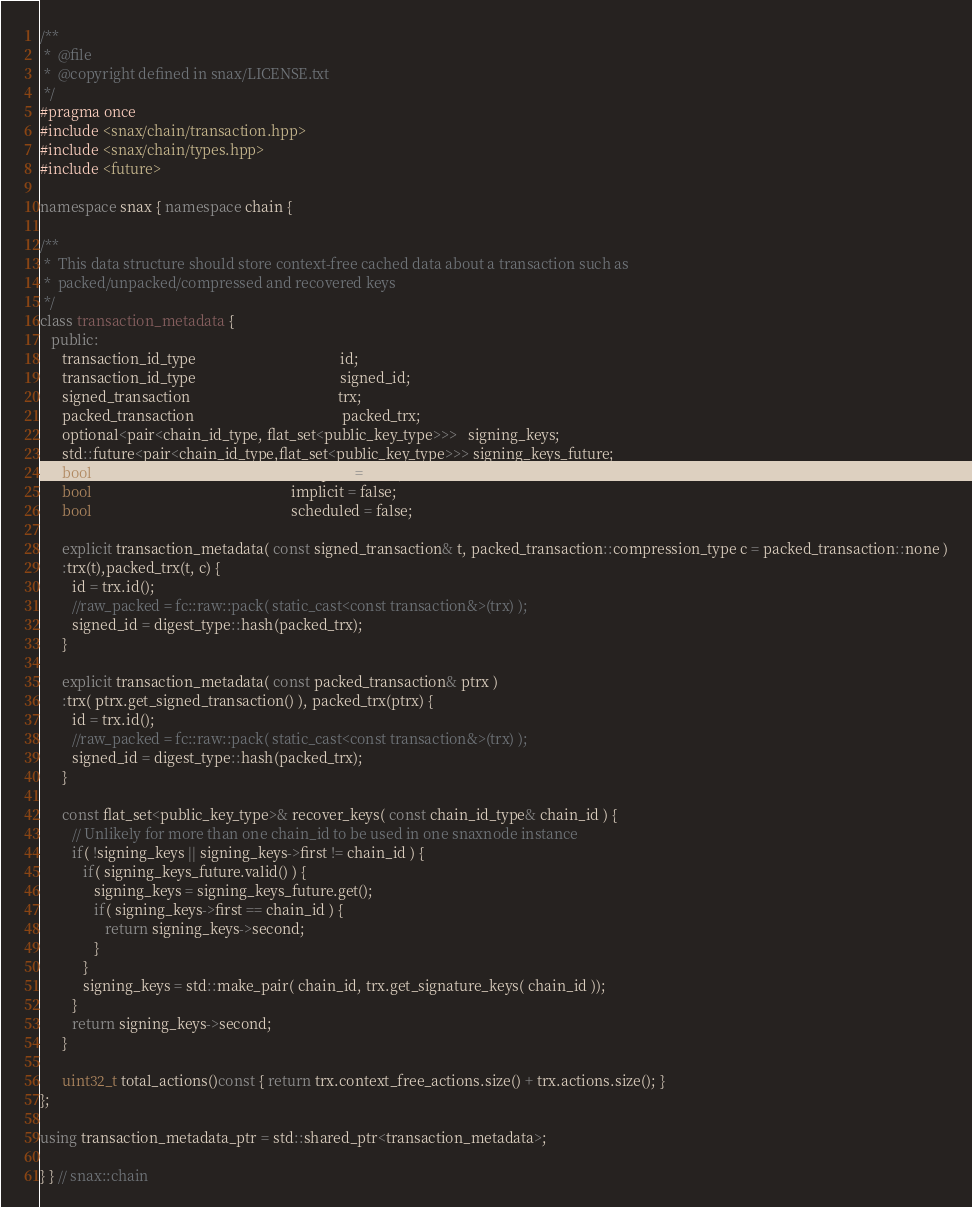<code> <loc_0><loc_0><loc_500><loc_500><_C++_>/**
 *  @file
 *  @copyright defined in snax/LICENSE.txt
 */
#pragma once
#include <snax/chain/transaction.hpp>
#include <snax/chain/types.hpp>
#include <future>

namespace snax { namespace chain {

/**
 *  This data structure should store context-free cached data about a transaction such as
 *  packed/unpacked/compressed and recovered keys
 */
class transaction_metadata {
   public:
      transaction_id_type                                        id;
      transaction_id_type                                        signed_id;
      signed_transaction                                         trx;
      packed_transaction                                         packed_trx;
      optional<pair<chain_id_type, flat_set<public_key_type>>>   signing_keys;
      std::future<pair<chain_id_type,flat_set<public_key_type>>> signing_keys_future;
      bool                                                       accepted = false;
      bool                                                       implicit = false;
      bool                                                       scheduled = false;

      explicit transaction_metadata( const signed_transaction& t, packed_transaction::compression_type c = packed_transaction::none )
      :trx(t),packed_trx(t, c) {
         id = trx.id();
         //raw_packed = fc::raw::pack( static_cast<const transaction&>(trx) );
         signed_id = digest_type::hash(packed_trx);
      }

      explicit transaction_metadata( const packed_transaction& ptrx )
      :trx( ptrx.get_signed_transaction() ), packed_trx(ptrx) {
         id = trx.id();
         //raw_packed = fc::raw::pack( static_cast<const transaction&>(trx) );
         signed_id = digest_type::hash(packed_trx);
      }

      const flat_set<public_key_type>& recover_keys( const chain_id_type& chain_id ) {
         // Unlikely for more than one chain_id to be used in one snaxnode instance
         if( !signing_keys || signing_keys->first != chain_id ) {
            if( signing_keys_future.valid() ) {
               signing_keys = signing_keys_future.get();
               if( signing_keys->first == chain_id ) {
                  return signing_keys->second;
               }
            }
            signing_keys = std::make_pair( chain_id, trx.get_signature_keys( chain_id ));
         }
         return signing_keys->second;
      }

      uint32_t total_actions()const { return trx.context_free_actions.size() + trx.actions.size(); }
};

using transaction_metadata_ptr = std::shared_ptr<transaction_metadata>;

} } // snax::chain
</code> 